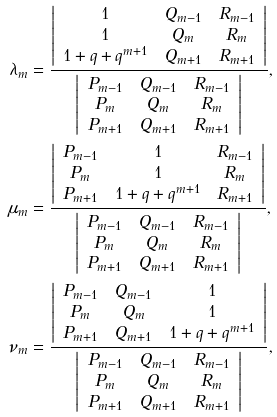<formula> <loc_0><loc_0><loc_500><loc_500>\lambda _ { m } & = \frac { \left | \begin{array} { c c c } 1 & Q _ { m - 1 } & R _ { m - 1 } \\ 1 & Q _ { m } & R _ { m } \\ 1 + q + q ^ { m + 1 } & Q _ { m + 1 } & R _ { m + 1 } \\ \end{array} \right | } { \left | \begin{array} { c c c } P _ { m - 1 } & Q _ { m - 1 } & R _ { m - 1 } \\ P _ { m } & Q _ { m } & R _ { m } \\ P _ { m + 1 } & Q _ { m + 1 } & R _ { m + 1 } \\ \end{array} \right | } , \\ \mu _ { m } & = \frac { \left | \begin{array} { c c c } P _ { m - 1 } & 1 & R _ { m - 1 } \\ P _ { m } & 1 & R _ { m } \\ P _ { m + 1 } & 1 + q + q ^ { m + 1 } & R _ { m + 1 } \\ \end{array} \right | } { \left | \begin{array} { c c c } P _ { m - 1 } & Q _ { m - 1 } & R _ { m - 1 } \\ P _ { m } & Q _ { m } & R _ { m } \\ P _ { m + 1 } & Q _ { m + 1 } & R _ { m + 1 } \\ \end{array} \right | } , \\ \nu _ { m } & = \frac { \left | \begin{array} { c c c } P _ { m - 1 } & Q _ { m - 1 } & 1 \\ P _ { m } & Q _ { m } & 1 \\ P _ { m + 1 } & Q _ { m + 1 } & 1 + q + q ^ { m + 1 } \\ \end{array} \right | } { \left | \begin{array} { c c c } P _ { m - 1 } & Q _ { m - 1 } & R _ { m - 1 } \\ P _ { m } & Q _ { m } & R _ { m } \\ P _ { m + 1 } & Q _ { m + 1 } & R _ { m + 1 } \\ \end{array} \right | } ,</formula> 